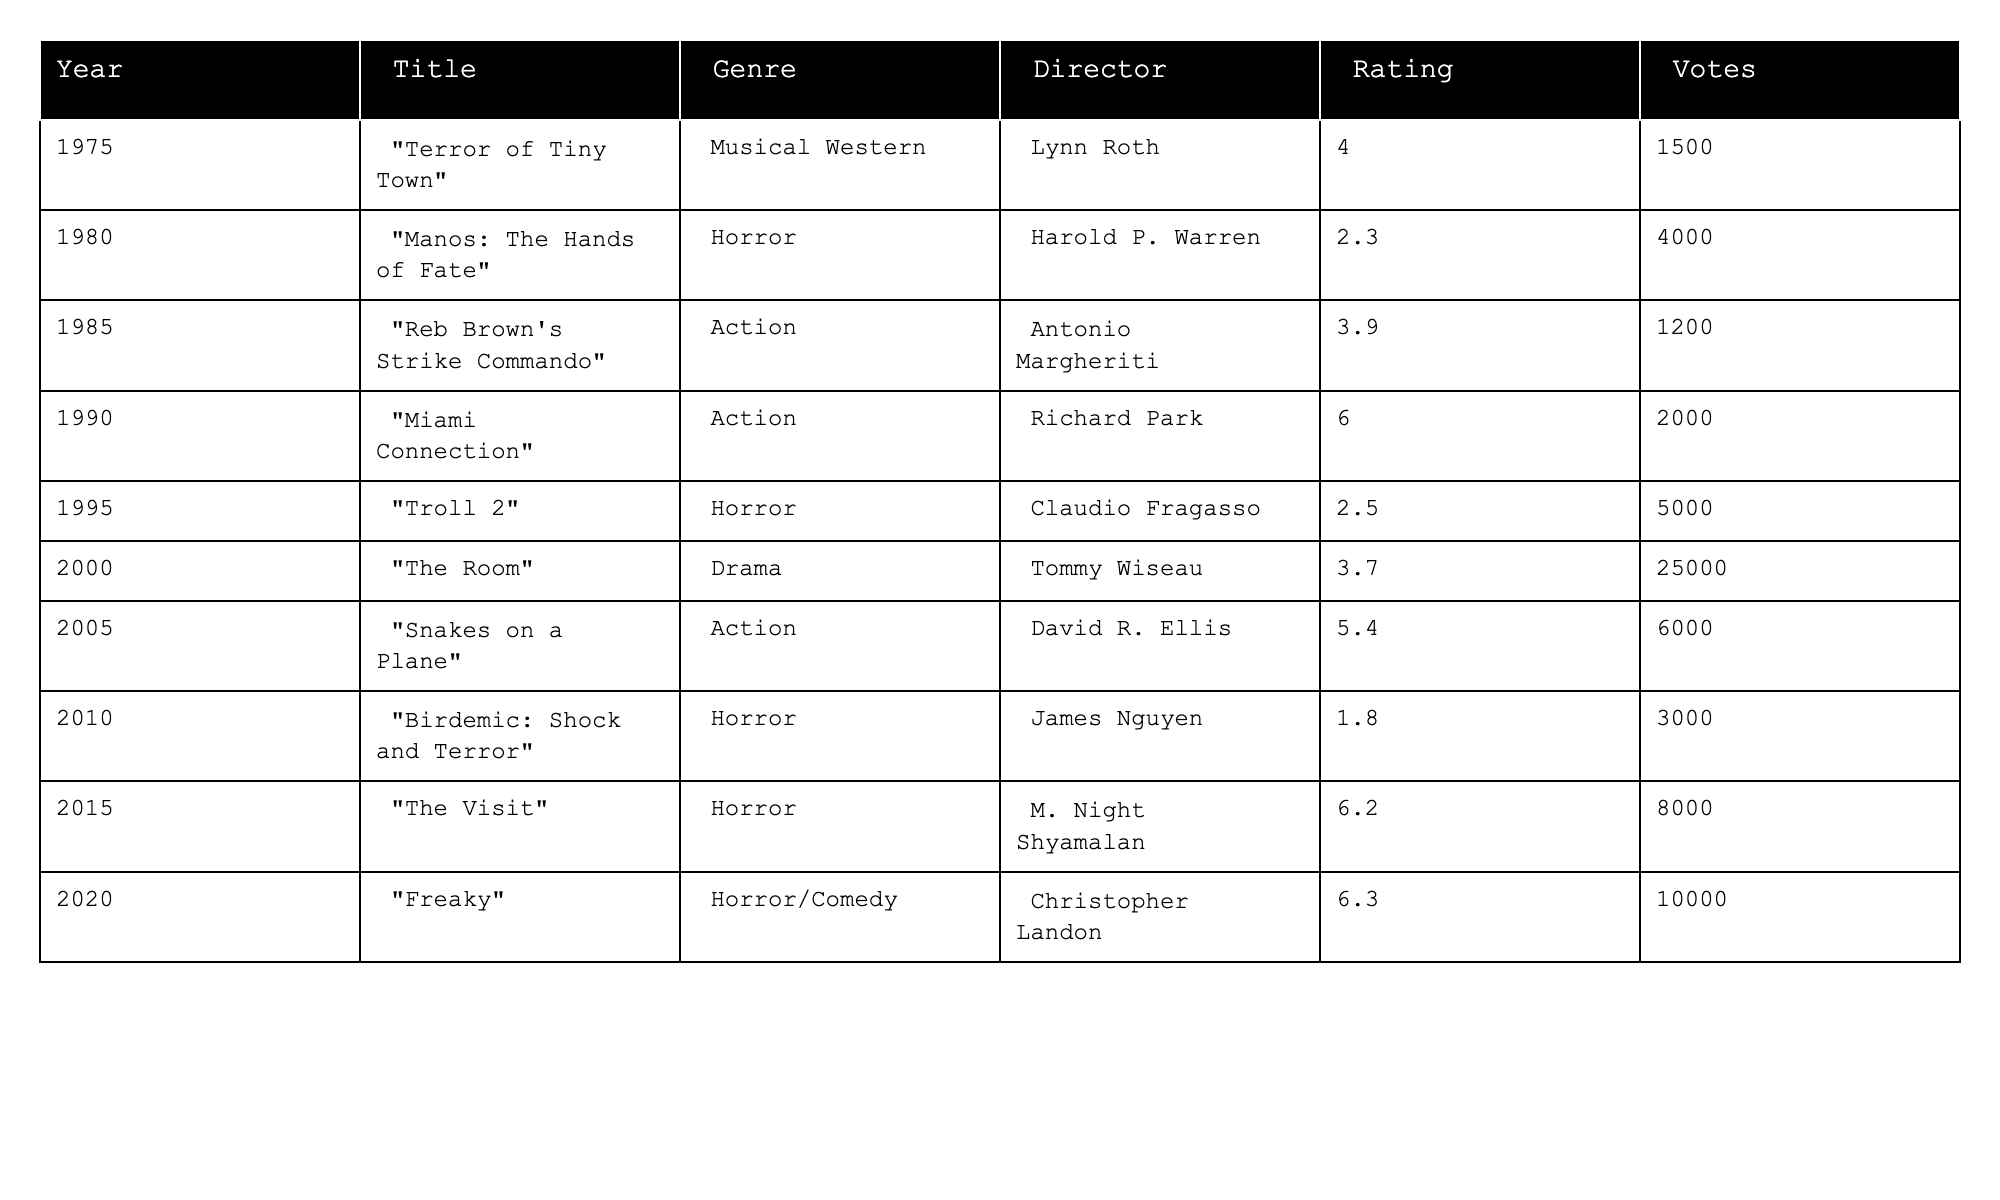What is the highest-rated B-movie in the table? The highest rating in the table is 6.3, which corresponds to the movie "Freaky" from the year 2020.
Answer: 6.3 How many votes did "Troll 2" receive? "Troll 2" received 5000 votes as shown in the Votes column.
Answer: 5000 What is the average rating of the movies listed in the table? The ratings are 4.0, 2.3, 3.9, 6.0, 2.5, 3.7, 5.4, 1.8, 6.2, and 6.3. Summing these gives 36.1, and there are 10 movies, so the average rating is 36.1 / 10 = 3.61.
Answer: 3.61 Which genre has the highest average rating based on the table data? The genres in the table are analyzed by their ratings: Musical Western = 4.0, Horror = (2.3 + 2.5 + 1.8 + 6.2 + 6.3)/5 = 2.82, Action = (3.9 + 6.0 + 5.4)/3 = 5.07, Drama = 3.7. The highest average rating is for Action at 5.07.
Answer: Action Did "The Room" receive more votes than "Birdemic: Shock and Terror"? "The Room" had 25000 votes, whereas "Birdemic: Shock and Terror" had 3000 votes. Since 25000 is greater than 3000, the answer is yes.
Answer: Yes What is the difference in votes between the highest and lowest-rated movies? The highest rating is 6.3 (Freaky, 10000 votes) and the lowest is 1.8 (Birdemic: Shock and Terror, 3000 votes). The difference in votes is 10000 - 3000 = 7000.
Answer: 7000 How many genres are represented in the table? There are four distinct genres in the table: Musical Western, Horror, Action, and Drama.
Answer: 4 Which year had the least popular movie based on votes? "The Visit" in 2015 had 8000 votes, which is fewer than "The Room" and "Troll 2" indicating a lower popularity relative to its rating. However, the least popular movie by total vote count is "Birdemic: Shock and Terror" with 3000 votes.
Answer: 2010 What percentage of the total votes did "Miami Connection" receive? The total votes for all movies are 1500 + 4000 + 1200 + 2000 + 5000 + 25000 + 6000 + 3000 + 8000 + 10000 = 53600. "Miami Connection" has 2000 votes, so the percentage is (2000 / 53600) * 100 ≈ 3.73%.
Answer: 3.73% 